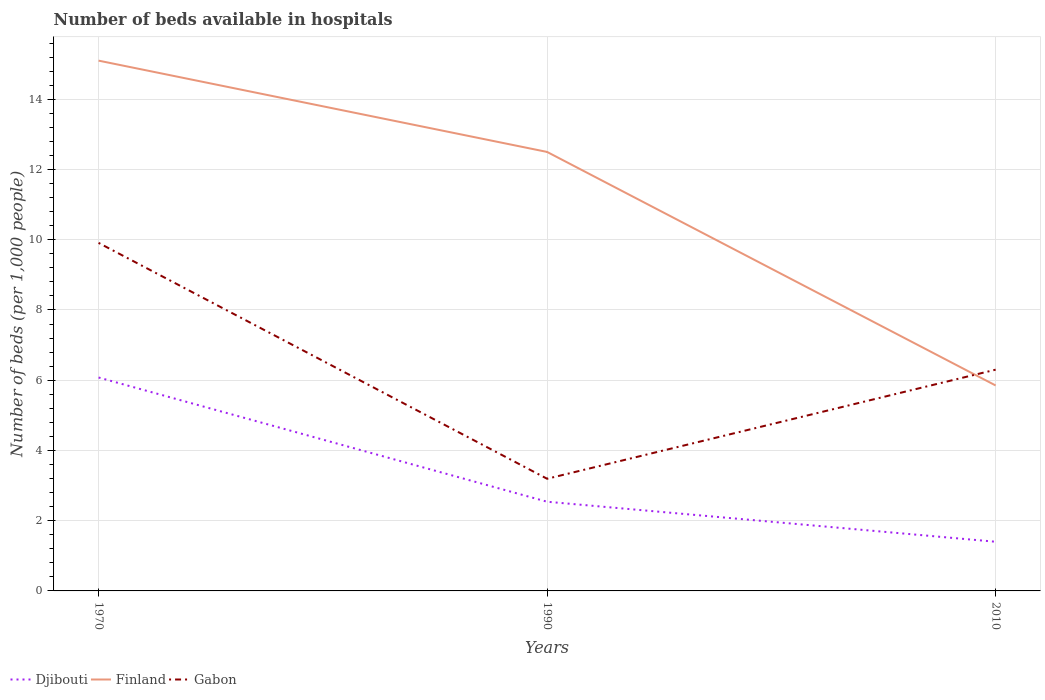How many different coloured lines are there?
Provide a succinct answer. 3. Is the number of lines equal to the number of legend labels?
Ensure brevity in your answer.  Yes. Across all years, what is the maximum number of beds in the hospiatls of in Gabon?
Make the answer very short. 3.19. What is the total number of beds in the hospiatls of in Finland in the graph?
Your answer should be compact. 6.65. What is the difference between the highest and the second highest number of beds in the hospiatls of in Finland?
Your answer should be compact. 9.25. What is the difference between the highest and the lowest number of beds in the hospiatls of in Djibouti?
Your answer should be compact. 1. Is the number of beds in the hospiatls of in Gabon strictly greater than the number of beds in the hospiatls of in Djibouti over the years?
Make the answer very short. No. What is the difference between two consecutive major ticks on the Y-axis?
Your answer should be compact. 2. Does the graph contain any zero values?
Offer a very short reply. No. Does the graph contain grids?
Your answer should be very brief. Yes. How many legend labels are there?
Ensure brevity in your answer.  3. What is the title of the graph?
Provide a short and direct response. Number of beds available in hospitals. Does "Uruguay" appear as one of the legend labels in the graph?
Ensure brevity in your answer.  No. What is the label or title of the Y-axis?
Ensure brevity in your answer.  Number of beds (per 1,0 people). What is the Number of beds (per 1,000 people) in Djibouti in 1970?
Your answer should be very brief. 6.08. What is the Number of beds (per 1,000 people) in Finland in 1970?
Offer a terse response. 15.1. What is the Number of beds (per 1,000 people) in Gabon in 1970?
Keep it short and to the point. 9.91. What is the Number of beds (per 1,000 people) in Djibouti in 1990?
Ensure brevity in your answer.  2.54. What is the Number of beds (per 1,000 people) in Finland in 1990?
Provide a short and direct response. 12.5. What is the Number of beds (per 1,000 people) in Gabon in 1990?
Ensure brevity in your answer.  3.19. What is the Number of beds (per 1,000 people) of Djibouti in 2010?
Keep it short and to the point. 1.4. What is the Number of beds (per 1,000 people) of Finland in 2010?
Ensure brevity in your answer.  5.85. What is the Number of beds (per 1,000 people) in Gabon in 2010?
Offer a terse response. 6.3. Across all years, what is the maximum Number of beds (per 1,000 people) in Djibouti?
Your answer should be compact. 6.08. Across all years, what is the maximum Number of beds (per 1,000 people) in Finland?
Your answer should be very brief. 15.1. Across all years, what is the maximum Number of beds (per 1,000 people) of Gabon?
Offer a terse response. 9.91. Across all years, what is the minimum Number of beds (per 1,000 people) of Finland?
Make the answer very short. 5.85. Across all years, what is the minimum Number of beds (per 1,000 people) in Gabon?
Offer a terse response. 3.19. What is the total Number of beds (per 1,000 people) in Djibouti in the graph?
Provide a succinct answer. 10.02. What is the total Number of beds (per 1,000 people) of Finland in the graph?
Provide a succinct answer. 33.45. What is the total Number of beds (per 1,000 people) in Gabon in the graph?
Provide a short and direct response. 19.4. What is the difference between the Number of beds (per 1,000 people) of Djibouti in 1970 and that in 1990?
Ensure brevity in your answer.  3.54. What is the difference between the Number of beds (per 1,000 people) in Gabon in 1970 and that in 1990?
Your response must be concise. 6.72. What is the difference between the Number of beds (per 1,000 people) in Djibouti in 1970 and that in 2010?
Make the answer very short. 4.68. What is the difference between the Number of beds (per 1,000 people) in Finland in 1970 and that in 2010?
Make the answer very short. 9.25. What is the difference between the Number of beds (per 1,000 people) of Gabon in 1970 and that in 2010?
Provide a succinct answer. 3.61. What is the difference between the Number of beds (per 1,000 people) of Djibouti in 1990 and that in 2010?
Give a very brief answer. 1.14. What is the difference between the Number of beds (per 1,000 people) of Finland in 1990 and that in 2010?
Ensure brevity in your answer.  6.65. What is the difference between the Number of beds (per 1,000 people) in Gabon in 1990 and that in 2010?
Provide a short and direct response. -3.11. What is the difference between the Number of beds (per 1,000 people) in Djibouti in 1970 and the Number of beds (per 1,000 people) in Finland in 1990?
Your answer should be very brief. -6.42. What is the difference between the Number of beds (per 1,000 people) in Djibouti in 1970 and the Number of beds (per 1,000 people) in Gabon in 1990?
Ensure brevity in your answer.  2.88. What is the difference between the Number of beds (per 1,000 people) of Finland in 1970 and the Number of beds (per 1,000 people) of Gabon in 1990?
Your answer should be very brief. 11.91. What is the difference between the Number of beds (per 1,000 people) in Djibouti in 1970 and the Number of beds (per 1,000 people) in Finland in 2010?
Provide a succinct answer. 0.23. What is the difference between the Number of beds (per 1,000 people) of Djibouti in 1970 and the Number of beds (per 1,000 people) of Gabon in 2010?
Provide a short and direct response. -0.22. What is the difference between the Number of beds (per 1,000 people) of Finland in 1970 and the Number of beds (per 1,000 people) of Gabon in 2010?
Provide a succinct answer. 8.8. What is the difference between the Number of beds (per 1,000 people) of Djibouti in 1990 and the Number of beds (per 1,000 people) of Finland in 2010?
Your answer should be compact. -3.31. What is the difference between the Number of beds (per 1,000 people) of Djibouti in 1990 and the Number of beds (per 1,000 people) of Gabon in 2010?
Make the answer very short. -3.76. What is the average Number of beds (per 1,000 people) in Djibouti per year?
Offer a terse response. 3.34. What is the average Number of beds (per 1,000 people) in Finland per year?
Your answer should be compact. 11.15. What is the average Number of beds (per 1,000 people) in Gabon per year?
Provide a short and direct response. 6.47. In the year 1970, what is the difference between the Number of beds (per 1,000 people) of Djibouti and Number of beds (per 1,000 people) of Finland?
Offer a very short reply. -9.02. In the year 1970, what is the difference between the Number of beds (per 1,000 people) in Djibouti and Number of beds (per 1,000 people) in Gabon?
Your answer should be compact. -3.83. In the year 1970, what is the difference between the Number of beds (per 1,000 people) of Finland and Number of beds (per 1,000 people) of Gabon?
Your answer should be compact. 5.19. In the year 1990, what is the difference between the Number of beds (per 1,000 people) of Djibouti and Number of beds (per 1,000 people) of Finland?
Your response must be concise. -9.96. In the year 1990, what is the difference between the Number of beds (per 1,000 people) of Djibouti and Number of beds (per 1,000 people) of Gabon?
Offer a very short reply. -0.65. In the year 1990, what is the difference between the Number of beds (per 1,000 people) of Finland and Number of beds (per 1,000 people) of Gabon?
Keep it short and to the point. 9.31. In the year 2010, what is the difference between the Number of beds (per 1,000 people) of Djibouti and Number of beds (per 1,000 people) of Finland?
Keep it short and to the point. -4.45. In the year 2010, what is the difference between the Number of beds (per 1,000 people) in Djibouti and Number of beds (per 1,000 people) in Gabon?
Your response must be concise. -4.9. In the year 2010, what is the difference between the Number of beds (per 1,000 people) of Finland and Number of beds (per 1,000 people) of Gabon?
Offer a terse response. -0.45. What is the ratio of the Number of beds (per 1,000 people) in Djibouti in 1970 to that in 1990?
Your response must be concise. 2.39. What is the ratio of the Number of beds (per 1,000 people) in Finland in 1970 to that in 1990?
Make the answer very short. 1.21. What is the ratio of the Number of beds (per 1,000 people) of Gabon in 1970 to that in 1990?
Your response must be concise. 3.1. What is the ratio of the Number of beds (per 1,000 people) in Djibouti in 1970 to that in 2010?
Offer a very short reply. 4.34. What is the ratio of the Number of beds (per 1,000 people) in Finland in 1970 to that in 2010?
Your answer should be very brief. 2.58. What is the ratio of the Number of beds (per 1,000 people) in Gabon in 1970 to that in 2010?
Keep it short and to the point. 1.57. What is the ratio of the Number of beds (per 1,000 people) in Djibouti in 1990 to that in 2010?
Offer a very short reply. 1.81. What is the ratio of the Number of beds (per 1,000 people) in Finland in 1990 to that in 2010?
Your answer should be very brief. 2.14. What is the ratio of the Number of beds (per 1,000 people) of Gabon in 1990 to that in 2010?
Your response must be concise. 0.51. What is the difference between the highest and the second highest Number of beds (per 1,000 people) of Djibouti?
Provide a short and direct response. 3.54. What is the difference between the highest and the second highest Number of beds (per 1,000 people) in Gabon?
Offer a terse response. 3.61. What is the difference between the highest and the lowest Number of beds (per 1,000 people) in Djibouti?
Keep it short and to the point. 4.68. What is the difference between the highest and the lowest Number of beds (per 1,000 people) in Finland?
Give a very brief answer. 9.25. What is the difference between the highest and the lowest Number of beds (per 1,000 people) of Gabon?
Make the answer very short. 6.72. 